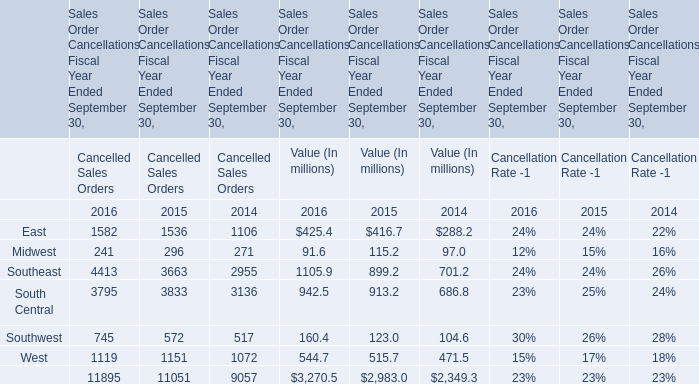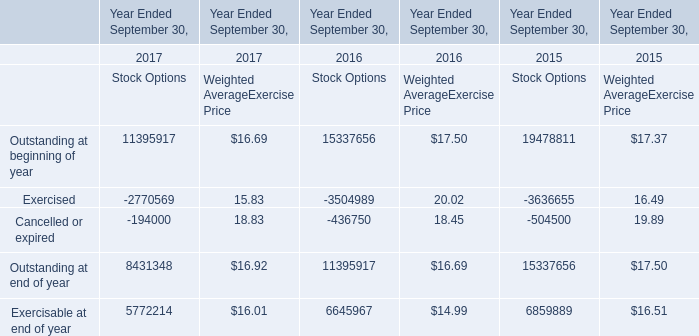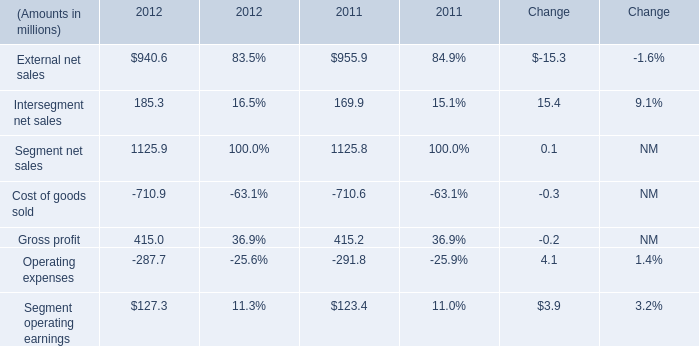What's the average of the Outstanding at beginning of year for Stock Options in the years where Southeast for Cancelled Sales Orders is greater than 3000? 
Computations: ((15337656 + 19478811) / 2)
Answer: 17408233.5. 